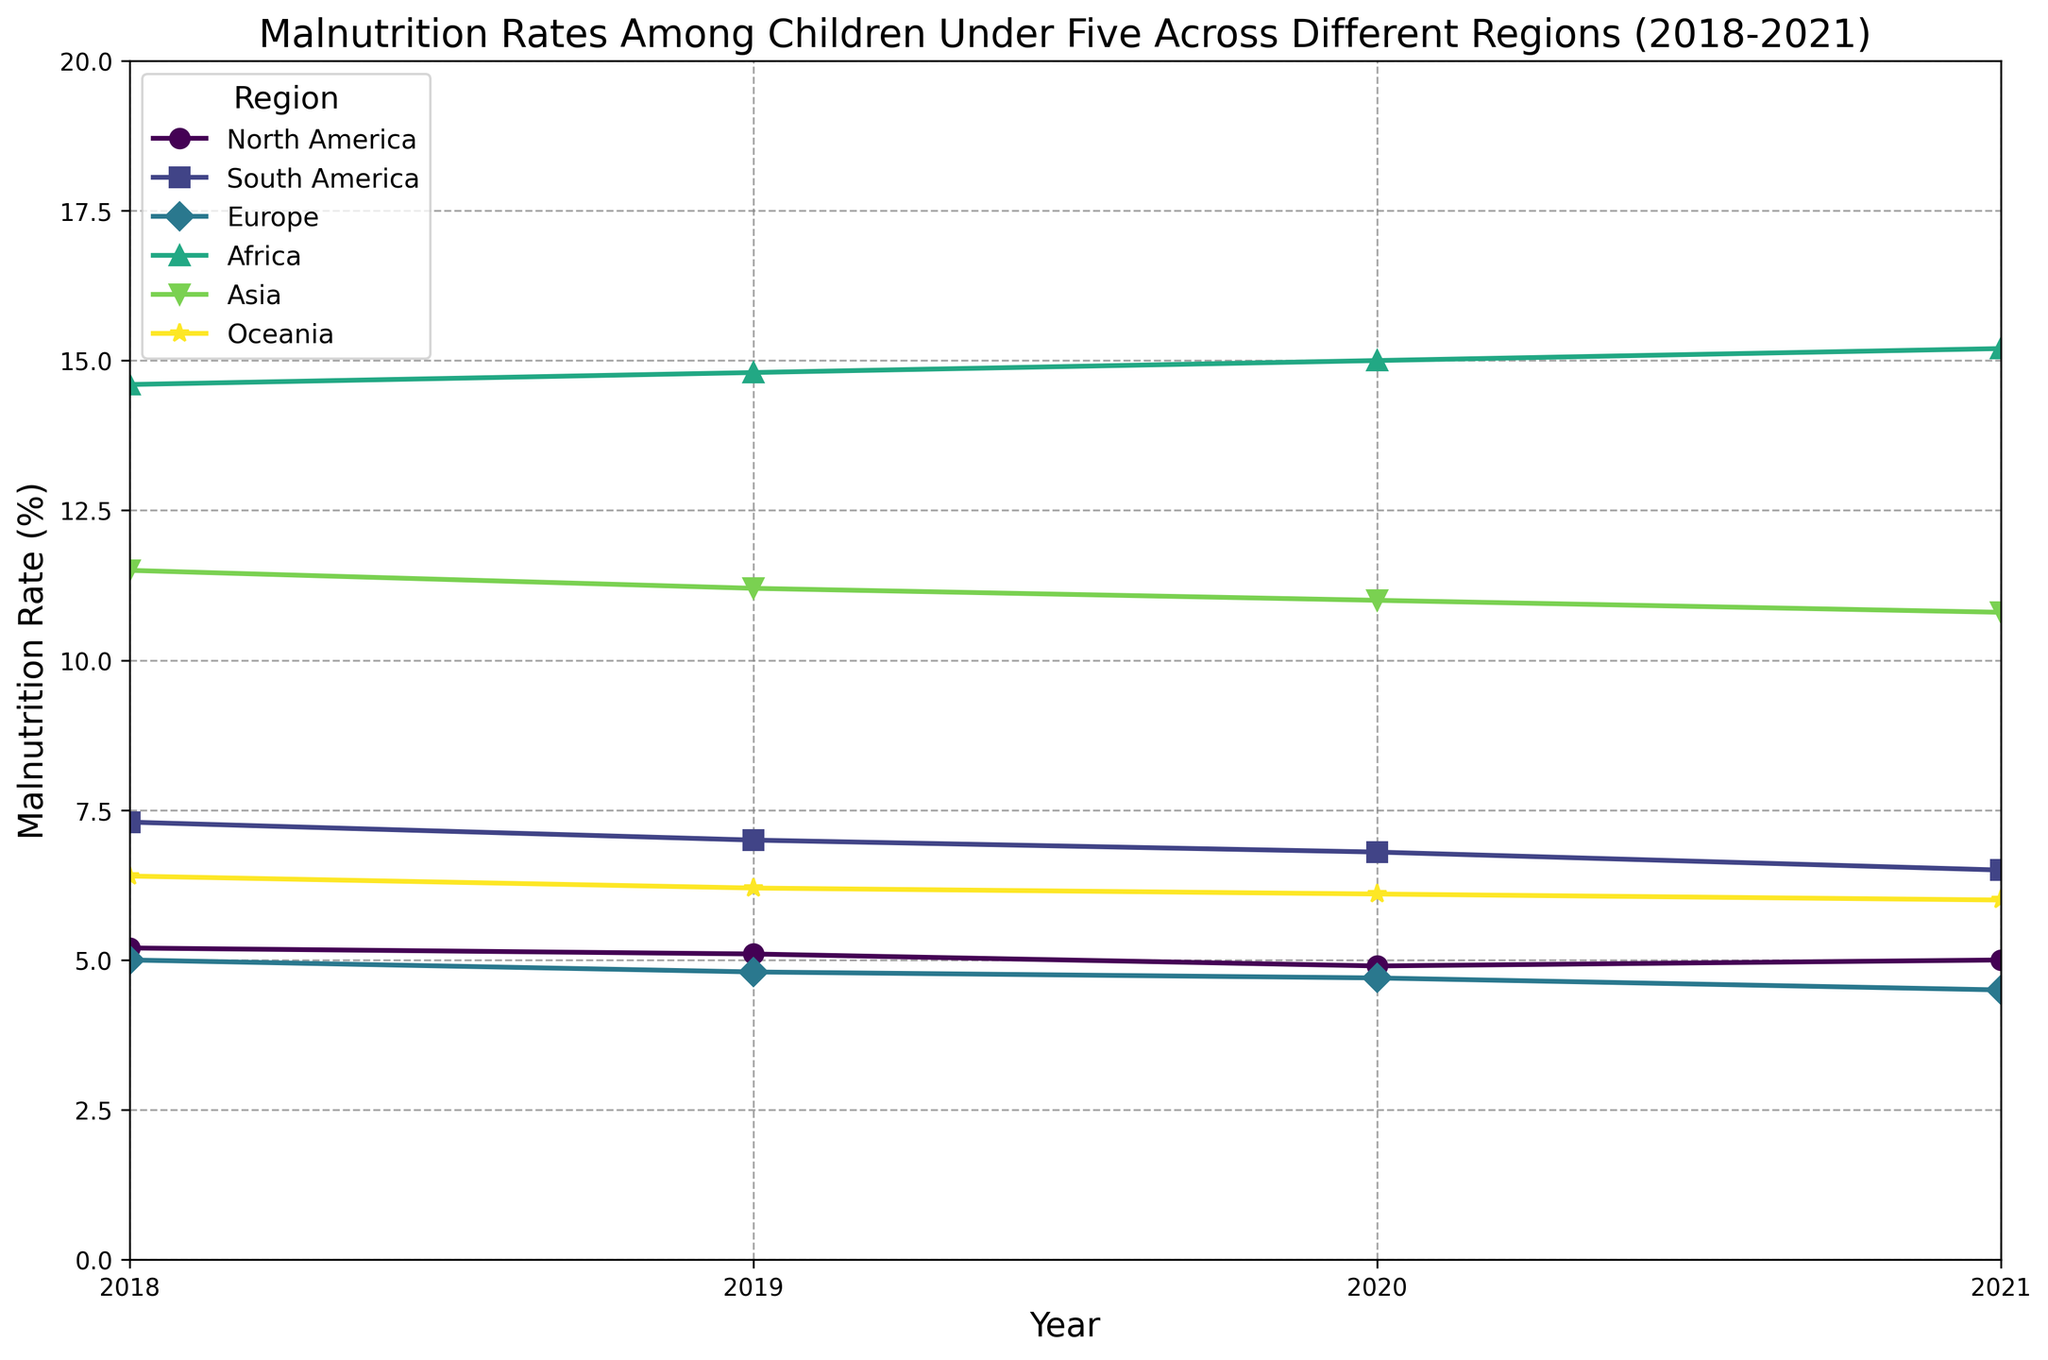What region has the highest malnutrition rate in 2021? To determine this, we observe the points for each region in the year 2021. Africa has the highest malnutrition rate in 2021 with a value of 15.2%.
Answer: Africa Which region shows the greatest decrease in malnutrition rates from 2018 to 2021? To find the region with the greatest decrease, we compare the malnutrition rates in 2018 and 2021 for each region and calculate the difference. South America shows a decrease from 7.3% in 2018 to 6.5% in 2021, a reduction of 0.8%.
Answer: South America How did the malnutrition rate in North America change from 2018 to 2021? By examining the malnutrition rates for North America in 2018 (5.2%) and 2021 (5.0%), we can see that the rate decreased by 0.2%.
Answer: Decreased by 0.2% Compare the malnutrition rates between Africa and Asia in 2020. Which region had a higher rate? We look at the malnutrition rates for Africa and Asia in 2020. Africa had a rate of 15.0%, while Asia had a rate of 11.0%. Therefore, Africa had a higher rate.
Answer: Africa What's the average malnutrition rate for Europe from 2018 to 2021? To find the average rate, sum the rates for Europe across the years (5.0% + 4.8% + 4.7% + 4.5%) and then divide by 4. The total is 19.0%, which when divided by 4 gives 4.75%.
Answer: 4.75% Which region shows an increasing trend in malnutrition rates from 2018 to 2021? By studying the trend lines for each region, we see that Africa is the only region with an increasing trend, moving from 14.6% in 2018 to 15.2% in 2021.
Answer: Africa What is the difference in malnutrition rates between Oceania and South America in 2021? Oceania's rate in 2021 is 6.0%, and South America's rate is 6.5%. The difference between these two rates is 6.5% - 6.0% = 0.5%.
Answer: 0.5% Which region has the smallest fluctuation in malnutrition rates between 2018 and 2021? To determine this, we check the change magnitude for each region. North America's rates ranged from 5.2% to 5.0%, a fluctuation of 0.2%, which is the smallest among the regions.
Answer: North America Comparing the trends for Asia and Europe, which region experienced a more consistent decrease in malnutrition rates from 2018 to 2021? Both Asia and Europe show a decreasing trend. However, Europe shows a decrease from 5.0% to 4.5% (by 0.5) with slight variations year by year, while Asia shows a decrease from 11.5% to 10.8% (by 0.7). Thus, Europe had a more consistent decrease.
Answer: Europe 